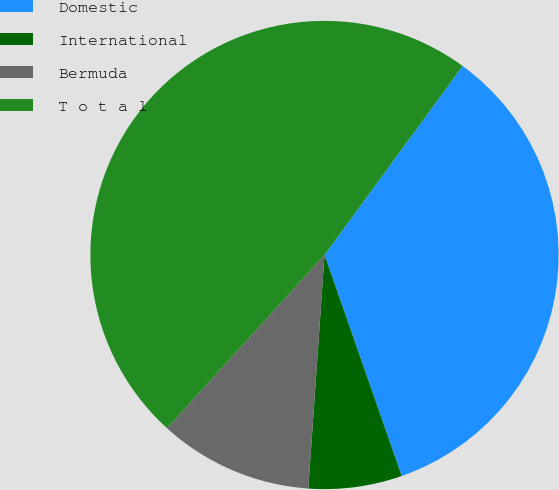Convert chart. <chart><loc_0><loc_0><loc_500><loc_500><pie_chart><fcel>Domestic<fcel>International<fcel>Bermuda<fcel>T o t a l<nl><fcel>34.61%<fcel>6.45%<fcel>10.64%<fcel>48.3%<nl></chart> 